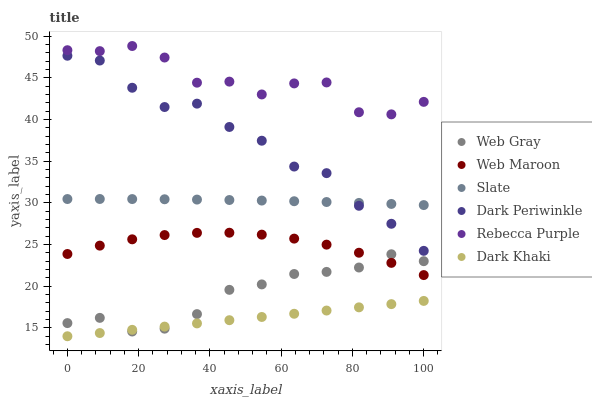Does Dark Khaki have the minimum area under the curve?
Answer yes or no. Yes. Does Rebecca Purple have the maximum area under the curve?
Answer yes or no. Yes. Does Slate have the minimum area under the curve?
Answer yes or no. No. Does Slate have the maximum area under the curve?
Answer yes or no. No. Is Dark Khaki the smoothest?
Answer yes or no. Yes. Is Rebecca Purple the roughest?
Answer yes or no. Yes. Is Slate the smoothest?
Answer yes or no. No. Is Slate the roughest?
Answer yes or no. No. Does Dark Khaki have the lowest value?
Answer yes or no. Yes. Does Slate have the lowest value?
Answer yes or no. No. Does Rebecca Purple have the highest value?
Answer yes or no. Yes. Does Slate have the highest value?
Answer yes or no. No. Is Web Maroon less than Slate?
Answer yes or no. Yes. Is Dark Periwinkle greater than Dark Khaki?
Answer yes or no. Yes. Does Dark Khaki intersect Web Gray?
Answer yes or no. Yes. Is Dark Khaki less than Web Gray?
Answer yes or no. No. Is Dark Khaki greater than Web Gray?
Answer yes or no. No. Does Web Maroon intersect Slate?
Answer yes or no. No. 